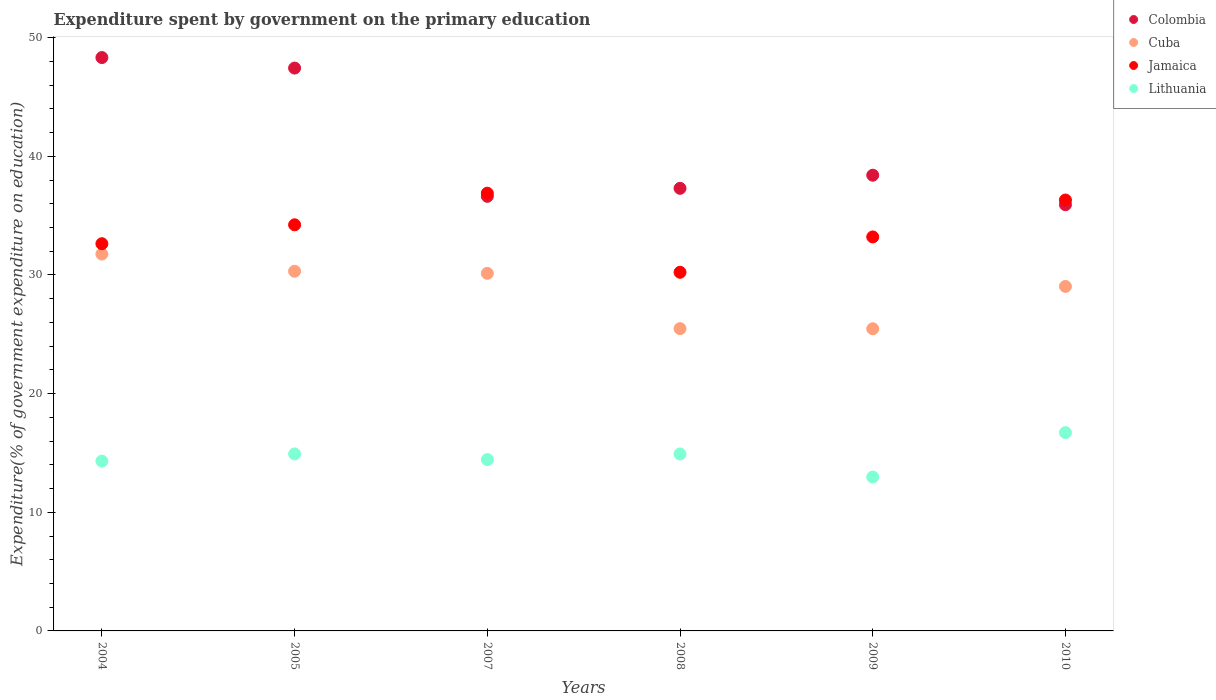What is the expenditure spent by government on the primary education in Cuba in 2004?
Offer a very short reply. 31.76. Across all years, what is the maximum expenditure spent by government on the primary education in Cuba?
Your response must be concise. 31.76. Across all years, what is the minimum expenditure spent by government on the primary education in Lithuania?
Keep it short and to the point. 12.97. In which year was the expenditure spent by government on the primary education in Colombia maximum?
Ensure brevity in your answer.  2004. What is the total expenditure spent by government on the primary education in Colombia in the graph?
Offer a very short reply. 244.02. What is the difference between the expenditure spent by government on the primary education in Colombia in 2007 and that in 2009?
Provide a short and direct response. -1.78. What is the difference between the expenditure spent by government on the primary education in Jamaica in 2004 and the expenditure spent by government on the primary education in Cuba in 2007?
Keep it short and to the point. 2.5. What is the average expenditure spent by government on the primary education in Jamaica per year?
Offer a very short reply. 33.92. In the year 2008, what is the difference between the expenditure spent by government on the primary education in Lithuania and expenditure spent by government on the primary education in Colombia?
Provide a short and direct response. -22.39. In how many years, is the expenditure spent by government on the primary education in Colombia greater than 42 %?
Your response must be concise. 2. What is the ratio of the expenditure spent by government on the primary education in Colombia in 2004 to that in 2010?
Offer a terse response. 1.35. Is the expenditure spent by government on the primary education in Lithuania in 2005 less than that in 2007?
Ensure brevity in your answer.  No. What is the difference between the highest and the second highest expenditure spent by government on the primary education in Jamaica?
Ensure brevity in your answer.  0.58. What is the difference between the highest and the lowest expenditure spent by government on the primary education in Colombia?
Give a very brief answer. 12.4. Is the sum of the expenditure spent by government on the primary education in Colombia in 2007 and 2009 greater than the maximum expenditure spent by government on the primary education in Lithuania across all years?
Provide a succinct answer. Yes. Is it the case that in every year, the sum of the expenditure spent by government on the primary education in Colombia and expenditure spent by government on the primary education in Lithuania  is greater than the expenditure spent by government on the primary education in Cuba?
Provide a short and direct response. Yes. Is the expenditure spent by government on the primary education in Lithuania strictly greater than the expenditure spent by government on the primary education in Cuba over the years?
Offer a terse response. No. Is the expenditure spent by government on the primary education in Cuba strictly less than the expenditure spent by government on the primary education in Jamaica over the years?
Offer a terse response. Yes. How many years are there in the graph?
Make the answer very short. 6. Are the values on the major ticks of Y-axis written in scientific E-notation?
Provide a succinct answer. No. Does the graph contain grids?
Provide a succinct answer. No. Where does the legend appear in the graph?
Give a very brief answer. Top right. How many legend labels are there?
Your answer should be compact. 4. What is the title of the graph?
Offer a very short reply. Expenditure spent by government on the primary education. What is the label or title of the Y-axis?
Your answer should be very brief. Expenditure(% of government expenditure on education). What is the Expenditure(% of government expenditure on education) of Colombia in 2004?
Offer a terse response. 48.32. What is the Expenditure(% of government expenditure on education) in Cuba in 2004?
Provide a short and direct response. 31.76. What is the Expenditure(% of government expenditure on education) in Jamaica in 2004?
Provide a short and direct response. 32.63. What is the Expenditure(% of government expenditure on education) of Lithuania in 2004?
Ensure brevity in your answer.  14.31. What is the Expenditure(% of government expenditure on education) of Colombia in 2005?
Offer a very short reply. 47.44. What is the Expenditure(% of government expenditure on education) of Cuba in 2005?
Give a very brief answer. 30.31. What is the Expenditure(% of government expenditure on education) in Jamaica in 2005?
Ensure brevity in your answer.  34.23. What is the Expenditure(% of government expenditure on education) in Lithuania in 2005?
Give a very brief answer. 14.92. What is the Expenditure(% of government expenditure on education) in Colombia in 2007?
Your answer should be very brief. 36.63. What is the Expenditure(% of government expenditure on education) in Cuba in 2007?
Your response must be concise. 30.14. What is the Expenditure(% of government expenditure on education) in Jamaica in 2007?
Make the answer very short. 36.89. What is the Expenditure(% of government expenditure on education) of Lithuania in 2007?
Give a very brief answer. 14.44. What is the Expenditure(% of government expenditure on education) of Colombia in 2008?
Make the answer very short. 37.3. What is the Expenditure(% of government expenditure on education) in Cuba in 2008?
Give a very brief answer. 25.48. What is the Expenditure(% of government expenditure on education) in Jamaica in 2008?
Your response must be concise. 30.23. What is the Expenditure(% of government expenditure on education) in Lithuania in 2008?
Your answer should be compact. 14.92. What is the Expenditure(% of government expenditure on education) of Colombia in 2009?
Give a very brief answer. 38.41. What is the Expenditure(% of government expenditure on education) in Cuba in 2009?
Offer a very short reply. 25.47. What is the Expenditure(% of government expenditure on education) of Jamaica in 2009?
Your answer should be very brief. 33.21. What is the Expenditure(% of government expenditure on education) of Lithuania in 2009?
Offer a terse response. 12.97. What is the Expenditure(% of government expenditure on education) in Colombia in 2010?
Keep it short and to the point. 35.92. What is the Expenditure(% of government expenditure on education) of Cuba in 2010?
Keep it short and to the point. 29.04. What is the Expenditure(% of government expenditure on education) of Jamaica in 2010?
Keep it short and to the point. 36.32. What is the Expenditure(% of government expenditure on education) in Lithuania in 2010?
Keep it short and to the point. 16.71. Across all years, what is the maximum Expenditure(% of government expenditure on education) in Colombia?
Your answer should be very brief. 48.32. Across all years, what is the maximum Expenditure(% of government expenditure on education) in Cuba?
Offer a very short reply. 31.76. Across all years, what is the maximum Expenditure(% of government expenditure on education) in Jamaica?
Your response must be concise. 36.89. Across all years, what is the maximum Expenditure(% of government expenditure on education) of Lithuania?
Ensure brevity in your answer.  16.71. Across all years, what is the minimum Expenditure(% of government expenditure on education) of Colombia?
Your response must be concise. 35.92. Across all years, what is the minimum Expenditure(% of government expenditure on education) of Cuba?
Provide a succinct answer. 25.47. Across all years, what is the minimum Expenditure(% of government expenditure on education) in Jamaica?
Provide a succinct answer. 30.23. Across all years, what is the minimum Expenditure(% of government expenditure on education) of Lithuania?
Give a very brief answer. 12.97. What is the total Expenditure(% of government expenditure on education) of Colombia in the graph?
Your response must be concise. 244.02. What is the total Expenditure(% of government expenditure on education) in Cuba in the graph?
Your answer should be very brief. 172.19. What is the total Expenditure(% of government expenditure on education) of Jamaica in the graph?
Provide a short and direct response. 203.5. What is the total Expenditure(% of government expenditure on education) in Lithuania in the graph?
Your answer should be compact. 88.27. What is the difference between the Expenditure(% of government expenditure on education) of Colombia in 2004 and that in 2005?
Your answer should be compact. 0.89. What is the difference between the Expenditure(% of government expenditure on education) of Cuba in 2004 and that in 2005?
Ensure brevity in your answer.  1.45. What is the difference between the Expenditure(% of government expenditure on education) in Jamaica in 2004 and that in 2005?
Your answer should be very brief. -1.59. What is the difference between the Expenditure(% of government expenditure on education) of Lithuania in 2004 and that in 2005?
Keep it short and to the point. -0.6. What is the difference between the Expenditure(% of government expenditure on education) in Colombia in 2004 and that in 2007?
Ensure brevity in your answer.  11.7. What is the difference between the Expenditure(% of government expenditure on education) in Cuba in 2004 and that in 2007?
Offer a very short reply. 1.62. What is the difference between the Expenditure(% of government expenditure on education) of Jamaica in 2004 and that in 2007?
Your answer should be very brief. -4.26. What is the difference between the Expenditure(% of government expenditure on education) in Lithuania in 2004 and that in 2007?
Your answer should be very brief. -0.13. What is the difference between the Expenditure(% of government expenditure on education) of Colombia in 2004 and that in 2008?
Make the answer very short. 11.02. What is the difference between the Expenditure(% of government expenditure on education) of Cuba in 2004 and that in 2008?
Provide a succinct answer. 6.28. What is the difference between the Expenditure(% of government expenditure on education) in Jamaica in 2004 and that in 2008?
Provide a succinct answer. 2.41. What is the difference between the Expenditure(% of government expenditure on education) in Lithuania in 2004 and that in 2008?
Your answer should be very brief. -0.6. What is the difference between the Expenditure(% of government expenditure on education) in Colombia in 2004 and that in 2009?
Offer a terse response. 9.92. What is the difference between the Expenditure(% of government expenditure on education) of Cuba in 2004 and that in 2009?
Your answer should be compact. 6.29. What is the difference between the Expenditure(% of government expenditure on education) in Jamaica in 2004 and that in 2009?
Your answer should be compact. -0.57. What is the difference between the Expenditure(% of government expenditure on education) of Lithuania in 2004 and that in 2009?
Keep it short and to the point. 1.34. What is the difference between the Expenditure(% of government expenditure on education) of Colombia in 2004 and that in 2010?
Provide a short and direct response. 12.4. What is the difference between the Expenditure(% of government expenditure on education) of Cuba in 2004 and that in 2010?
Offer a very short reply. 2.73. What is the difference between the Expenditure(% of government expenditure on education) of Jamaica in 2004 and that in 2010?
Offer a very short reply. -3.68. What is the difference between the Expenditure(% of government expenditure on education) in Lithuania in 2004 and that in 2010?
Give a very brief answer. -2.4. What is the difference between the Expenditure(% of government expenditure on education) of Colombia in 2005 and that in 2007?
Your answer should be compact. 10.81. What is the difference between the Expenditure(% of government expenditure on education) of Cuba in 2005 and that in 2007?
Your answer should be compact. 0.17. What is the difference between the Expenditure(% of government expenditure on education) of Jamaica in 2005 and that in 2007?
Provide a short and direct response. -2.66. What is the difference between the Expenditure(% of government expenditure on education) of Lithuania in 2005 and that in 2007?
Ensure brevity in your answer.  0.47. What is the difference between the Expenditure(% of government expenditure on education) in Colombia in 2005 and that in 2008?
Your answer should be compact. 10.13. What is the difference between the Expenditure(% of government expenditure on education) in Cuba in 2005 and that in 2008?
Your answer should be compact. 4.83. What is the difference between the Expenditure(% of government expenditure on education) in Jamaica in 2005 and that in 2008?
Make the answer very short. 4. What is the difference between the Expenditure(% of government expenditure on education) of Lithuania in 2005 and that in 2008?
Provide a succinct answer. 0. What is the difference between the Expenditure(% of government expenditure on education) in Colombia in 2005 and that in 2009?
Your response must be concise. 9.03. What is the difference between the Expenditure(% of government expenditure on education) of Cuba in 2005 and that in 2009?
Your answer should be very brief. 4.85. What is the difference between the Expenditure(% of government expenditure on education) in Jamaica in 2005 and that in 2009?
Ensure brevity in your answer.  1.02. What is the difference between the Expenditure(% of government expenditure on education) of Lithuania in 2005 and that in 2009?
Provide a short and direct response. 1.95. What is the difference between the Expenditure(% of government expenditure on education) of Colombia in 2005 and that in 2010?
Offer a very short reply. 11.52. What is the difference between the Expenditure(% of government expenditure on education) in Cuba in 2005 and that in 2010?
Provide a succinct answer. 1.28. What is the difference between the Expenditure(% of government expenditure on education) in Jamaica in 2005 and that in 2010?
Your response must be concise. -2.09. What is the difference between the Expenditure(% of government expenditure on education) of Lithuania in 2005 and that in 2010?
Offer a very short reply. -1.8. What is the difference between the Expenditure(% of government expenditure on education) in Colombia in 2007 and that in 2008?
Make the answer very short. -0.67. What is the difference between the Expenditure(% of government expenditure on education) in Cuba in 2007 and that in 2008?
Offer a terse response. 4.66. What is the difference between the Expenditure(% of government expenditure on education) of Jamaica in 2007 and that in 2008?
Ensure brevity in your answer.  6.67. What is the difference between the Expenditure(% of government expenditure on education) in Lithuania in 2007 and that in 2008?
Give a very brief answer. -0.47. What is the difference between the Expenditure(% of government expenditure on education) of Colombia in 2007 and that in 2009?
Offer a terse response. -1.78. What is the difference between the Expenditure(% of government expenditure on education) of Cuba in 2007 and that in 2009?
Offer a terse response. 4.67. What is the difference between the Expenditure(% of government expenditure on education) in Jamaica in 2007 and that in 2009?
Provide a succinct answer. 3.69. What is the difference between the Expenditure(% of government expenditure on education) of Lithuania in 2007 and that in 2009?
Your response must be concise. 1.47. What is the difference between the Expenditure(% of government expenditure on education) in Colombia in 2007 and that in 2010?
Give a very brief answer. 0.71. What is the difference between the Expenditure(% of government expenditure on education) in Cuba in 2007 and that in 2010?
Offer a very short reply. 1.1. What is the difference between the Expenditure(% of government expenditure on education) in Jamaica in 2007 and that in 2010?
Offer a very short reply. 0.58. What is the difference between the Expenditure(% of government expenditure on education) in Lithuania in 2007 and that in 2010?
Your answer should be compact. -2.27. What is the difference between the Expenditure(% of government expenditure on education) of Colombia in 2008 and that in 2009?
Ensure brevity in your answer.  -1.1. What is the difference between the Expenditure(% of government expenditure on education) in Cuba in 2008 and that in 2009?
Offer a terse response. 0.01. What is the difference between the Expenditure(% of government expenditure on education) of Jamaica in 2008 and that in 2009?
Your response must be concise. -2.98. What is the difference between the Expenditure(% of government expenditure on education) in Lithuania in 2008 and that in 2009?
Make the answer very short. 1.95. What is the difference between the Expenditure(% of government expenditure on education) in Colombia in 2008 and that in 2010?
Make the answer very short. 1.38. What is the difference between the Expenditure(% of government expenditure on education) of Cuba in 2008 and that in 2010?
Provide a short and direct response. -3.56. What is the difference between the Expenditure(% of government expenditure on education) of Jamaica in 2008 and that in 2010?
Your answer should be very brief. -6.09. What is the difference between the Expenditure(% of government expenditure on education) of Lithuania in 2008 and that in 2010?
Your answer should be very brief. -1.8. What is the difference between the Expenditure(% of government expenditure on education) in Colombia in 2009 and that in 2010?
Provide a succinct answer. 2.49. What is the difference between the Expenditure(% of government expenditure on education) of Cuba in 2009 and that in 2010?
Your answer should be compact. -3.57. What is the difference between the Expenditure(% of government expenditure on education) of Jamaica in 2009 and that in 2010?
Your response must be concise. -3.11. What is the difference between the Expenditure(% of government expenditure on education) of Lithuania in 2009 and that in 2010?
Offer a very short reply. -3.74. What is the difference between the Expenditure(% of government expenditure on education) of Colombia in 2004 and the Expenditure(% of government expenditure on education) of Cuba in 2005?
Your response must be concise. 18.01. What is the difference between the Expenditure(% of government expenditure on education) of Colombia in 2004 and the Expenditure(% of government expenditure on education) of Jamaica in 2005?
Your response must be concise. 14.1. What is the difference between the Expenditure(% of government expenditure on education) of Colombia in 2004 and the Expenditure(% of government expenditure on education) of Lithuania in 2005?
Your answer should be very brief. 33.41. What is the difference between the Expenditure(% of government expenditure on education) in Cuba in 2004 and the Expenditure(% of government expenditure on education) in Jamaica in 2005?
Keep it short and to the point. -2.47. What is the difference between the Expenditure(% of government expenditure on education) of Cuba in 2004 and the Expenditure(% of government expenditure on education) of Lithuania in 2005?
Your response must be concise. 16.84. What is the difference between the Expenditure(% of government expenditure on education) in Jamaica in 2004 and the Expenditure(% of government expenditure on education) in Lithuania in 2005?
Your response must be concise. 17.72. What is the difference between the Expenditure(% of government expenditure on education) in Colombia in 2004 and the Expenditure(% of government expenditure on education) in Cuba in 2007?
Provide a short and direct response. 18.19. What is the difference between the Expenditure(% of government expenditure on education) of Colombia in 2004 and the Expenditure(% of government expenditure on education) of Jamaica in 2007?
Provide a short and direct response. 11.43. What is the difference between the Expenditure(% of government expenditure on education) in Colombia in 2004 and the Expenditure(% of government expenditure on education) in Lithuania in 2007?
Offer a terse response. 33.88. What is the difference between the Expenditure(% of government expenditure on education) of Cuba in 2004 and the Expenditure(% of government expenditure on education) of Jamaica in 2007?
Provide a short and direct response. -5.13. What is the difference between the Expenditure(% of government expenditure on education) in Cuba in 2004 and the Expenditure(% of government expenditure on education) in Lithuania in 2007?
Offer a terse response. 17.32. What is the difference between the Expenditure(% of government expenditure on education) of Jamaica in 2004 and the Expenditure(% of government expenditure on education) of Lithuania in 2007?
Keep it short and to the point. 18.19. What is the difference between the Expenditure(% of government expenditure on education) in Colombia in 2004 and the Expenditure(% of government expenditure on education) in Cuba in 2008?
Provide a short and direct response. 22.85. What is the difference between the Expenditure(% of government expenditure on education) in Colombia in 2004 and the Expenditure(% of government expenditure on education) in Jamaica in 2008?
Your answer should be very brief. 18.1. What is the difference between the Expenditure(% of government expenditure on education) of Colombia in 2004 and the Expenditure(% of government expenditure on education) of Lithuania in 2008?
Your answer should be very brief. 33.41. What is the difference between the Expenditure(% of government expenditure on education) in Cuba in 2004 and the Expenditure(% of government expenditure on education) in Jamaica in 2008?
Your answer should be very brief. 1.53. What is the difference between the Expenditure(% of government expenditure on education) of Cuba in 2004 and the Expenditure(% of government expenditure on education) of Lithuania in 2008?
Your answer should be compact. 16.85. What is the difference between the Expenditure(% of government expenditure on education) in Jamaica in 2004 and the Expenditure(% of government expenditure on education) in Lithuania in 2008?
Provide a succinct answer. 17.72. What is the difference between the Expenditure(% of government expenditure on education) in Colombia in 2004 and the Expenditure(% of government expenditure on education) in Cuba in 2009?
Ensure brevity in your answer.  22.86. What is the difference between the Expenditure(% of government expenditure on education) of Colombia in 2004 and the Expenditure(% of government expenditure on education) of Jamaica in 2009?
Ensure brevity in your answer.  15.12. What is the difference between the Expenditure(% of government expenditure on education) in Colombia in 2004 and the Expenditure(% of government expenditure on education) in Lithuania in 2009?
Your response must be concise. 35.35. What is the difference between the Expenditure(% of government expenditure on education) of Cuba in 2004 and the Expenditure(% of government expenditure on education) of Jamaica in 2009?
Ensure brevity in your answer.  -1.45. What is the difference between the Expenditure(% of government expenditure on education) in Cuba in 2004 and the Expenditure(% of government expenditure on education) in Lithuania in 2009?
Offer a very short reply. 18.79. What is the difference between the Expenditure(% of government expenditure on education) of Jamaica in 2004 and the Expenditure(% of government expenditure on education) of Lithuania in 2009?
Your answer should be compact. 19.66. What is the difference between the Expenditure(% of government expenditure on education) of Colombia in 2004 and the Expenditure(% of government expenditure on education) of Cuba in 2010?
Give a very brief answer. 19.29. What is the difference between the Expenditure(% of government expenditure on education) of Colombia in 2004 and the Expenditure(% of government expenditure on education) of Jamaica in 2010?
Offer a terse response. 12.01. What is the difference between the Expenditure(% of government expenditure on education) in Colombia in 2004 and the Expenditure(% of government expenditure on education) in Lithuania in 2010?
Your answer should be very brief. 31.61. What is the difference between the Expenditure(% of government expenditure on education) of Cuba in 2004 and the Expenditure(% of government expenditure on education) of Jamaica in 2010?
Give a very brief answer. -4.56. What is the difference between the Expenditure(% of government expenditure on education) in Cuba in 2004 and the Expenditure(% of government expenditure on education) in Lithuania in 2010?
Ensure brevity in your answer.  15.05. What is the difference between the Expenditure(% of government expenditure on education) in Jamaica in 2004 and the Expenditure(% of government expenditure on education) in Lithuania in 2010?
Give a very brief answer. 15.92. What is the difference between the Expenditure(% of government expenditure on education) of Colombia in 2005 and the Expenditure(% of government expenditure on education) of Cuba in 2007?
Offer a terse response. 17.3. What is the difference between the Expenditure(% of government expenditure on education) of Colombia in 2005 and the Expenditure(% of government expenditure on education) of Jamaica in 2007?
Offer a terse response. 10.55. What is the difference between the Expenditure(% of government expenditure on education) in Colombia in 2005 and the Expenditure(% of government expenditure on education) in Lithuania in 2007?
Your answer should be very brief. 32.99. What is the difference between the Expenditure(% of government expenditure on education) in Cuba in 2005 and the Expenditure(% of government expenditure on education) in Jamaica in 2007?
Offer a very short reply. -6.58. What is the difference between the Expenditure(% of government expenditure on education) in Cuba in 2005 and the Expenditure(% of government expenditure on education) in Lithuania in 2007?
Your answer should be compact. 15.87. What is the difference between the Expenditure(% of government expenditure on education) of Jamaica in 2005 and the Expenditure(% of government expenditure on education) of Lithuania in 2007?
Provide a short and direct response. 19.78. What is the difference between the Expenditure(% of government expenditure on education) in Colombia in 2005 and the Expenditure(% of government expenditure on education) in Cuba in 2008?
Offer a terse response. 21.96. What is the difference between the Expenditure(% of government expenditure on education) of Colombia in 2005 and the Expenditure(% of government expenditure on education) of Jamaica in 2008?
Make the answer very short. 17.21. What is the difference between the Expenditure(% of government expenditure on education) of Colombia in 2005 and the Expenditure(% of government expenditure on education) of Lithuania in 2008?
Offer a very short reply. 32.52. What is the difference between the Expenditure(% of government expenditure on education) of Cuba in 2005 and the Expenditure(% of government expenditure on education) of Jamaica in 2008?
Ensure brevity in your answer.  0.09. What is the difference between the Expenditure(% of government expenditure on education) of Cuba in 2005 and the Expenditure(% of government expenditure on education) of Lithuania in 2008?
Keep it short and to the point. 15.4. What is the difference between the Expenditure(% of government expenditure on education) of Jamaica in 2005 and the Expenditure(% of government expenditure on education) of Lithuania in 2008?
Give a very brief answer. 19.31. What is the difference between the Expenditure(% of government expenditure on education) of Colombia in 2005 and the Expenditure(% of government expenditure on education) of Cuba in 2009?
Keep it short and to the point. 21.97. What is the difference between the Expenditure(% of government expenditure on education) in Colombia in 2005 and the Expenditure(% of government expenditure on education) in Jamaica in 2009?
Your answer should be very brief. 14.23. What is the difference between the Expenditure(% of government expenditure on education) in Colombia in 2005 and the Expenditure(% of government expenditure on education) in Lithuania in 2009?
Provide a succinct answer. 34.47. What is the difference between the Expenditure(% of government expenditure on education) of Cuba in 2005 and the Expenditure(% of government expenditure on education) of Jamaica in 2009?
Provide a short and direct response. -2.89. What is the difference between the Expenditure(% of government expenditure on education) of Cuba in 2005 and the Expenditure(% of government expenditure on education) of Lithuania in 2009?
Give a very brief answer. 17.34. What is the difference between the Expenditure(% of government expenditure on education) in Jamaica in 2005 and the Expenditure(% of government expenditure on education) in Lithuania in 2009?
Give a very brief answer. 21.26. What is the difference between the Expenditure(% of government expenditure on education) in Colombia in 2005 and the Expenditure(% of government expenditure on education) in Cuba in 2010?
Offer a very short reply. 18.4. What is the difference between the Expenditure(% of government expenditure on education) of Colombia in 2005 and the Expenditure(% of government expenditure on education) of Jamaica in 2010?
Provide a short and direct response. 11.12. What is the difference between the Expenditure(% of government expenditure on education) of Colombia in 2005 and the Expenditure(% of government expenditure on education) of Lithuania in 2010?
Make the answer very short. 30.72. What is the difference between the Expenditure(% of government expenditure on education) in Cuba in 2005 and the Expenditure(% of government expenditure on education) in Jamaica in 2010?
Offer a terse response. -6. What is the difference between the Expenditure(% of government expenditure on education) in Cuba in 2005 and the Expenditure(% of government expenditure on education) in Lithuania in 2010?
Keep it short and to the point. 13.6. What is the difference between the Expenditure(% of government expenditure on education) of Jamaica in 2005 and the Expenditure(% of government expenditure on education) of Lithuania in 2010?
Make the answer very short. 17.51. What is the difference between the Expenditure(% of government expenditure on education) in Colombia in 2007 and the Expenditure(% of government expenditure on education) in Cuba in 2008?
Give a very brief answer. 11.15. What is the difference between the Expenditure(% of government expenditure on education) of Colombia in 2007 and the Expenditure(% of government expenditure on education) of Jamaica in 2008?
Your answer should be very brief. 6.4. What is the difference between the Expenditure(% of government expenditure on education) of Colombia in 2007 and the Expenditure(% of government expenditure on education) of Lithuania in 2008?
Provide a succinct answer. 21.71. What is the difference between the Expenditure(% of government expenditure on education) of Cuba in 2007 and the Expenditure(% of government expenditure on education) of Jamaica in 2008?
Give a very brief answer. -0.09. What is the difference between the Expenditure(% of government expenditure on education) of Cuba in 2007 and the Expenditure(% of government expenditure on education) of Lithuania in 2008?
Your answer should be compact. 15.22. What is the difference between the Expenditure(% of government expenditure on education) in Jamaica in 2007 and the Expenditure(% of government expenditure on education) in Lithuania in 2008?
Your response must be concise. 21.98. What is the difference between the Expenditure(% of government expenditure on education) in Colombia in 2007 and the Expenditure(% of government expenditure on education) in Cuba in 2009?
Ensure brevity in your answer.  11.16. What is the difference between the Expenditure(% of government expenditure on education) in Colombia in 2007 and the Expenditure(% of government expenditure on education) in Jamaica in 2009?
Keep it short and to the point. 3.42. What is the difference between the Expenditure(% of government expenditure on education) of Colombia in 2007 and the Expenditure(% of government expenditure on education) of Lithuania in 2009?
Offer a very short reply. 23.66. What is the difference between the Expenditure(% of government expenditure on education) of Cuba in 2007 and the Expenditure(% of government expenditure on education) of Jamaica in 2009?
Your answer should be compact. -3.07. What is the difference between the Expenditure(% of government expenditure on education) of Cuba in 2007 and the Expenditure(% of government expenditure on education) of Lithuania in 2009?
Your response must be concise. 17.17. What is the difference between the Expenditure(% of government expenditure on education) in Jamaica in 2007 and the Expenditure(% of government expenditure on education) in Lithuania in 2009?
Offer a terse response. 23.92. What is the difference between the Expenditure(% of government expenditure on education) of Colombia in 2007 and the Expenditure(% of government expenditure on education) of Cuba in 2010?
Give a very brief answer. 7.59. What is the difference between the Expenditure(% of government expenditure on education) of Colombia in 2007 and the Expenditure(% of government expenditure on education) of Jamaica in 2010?
Keep it short and to the point. 0.31. What is the difference between the Expenditure(% of government expenditure on education) in Colombia in 2007 and the Expenditure(% of government expenditure on education) in Lithuania in 2010?
Ensure brevity in your answer.  19.91. What is the difference between the Expenditure(% of government expenditure on education) in Cuba in 2007 and the Expenditure(% of government expenditure on education) in Jamaica in 2010?
Keep it short and to the point. -6.18. What is the difference between the Expenditure(% of government expenditure on education) of Cuba in 2007 and the Expenditure(% of government expenditure on education) of Lithuania in 2010?
Offer a very short reply. 13.42. What is the difference between the Expenditure(% of government expenditure on education) in Jamaica in 2007 and the Expenditure(% of government expenditure on education) in Lithuania in 2010?
Keep it short and to the point. 20.18. What is the difference between the Expenditure(% of government expenditure on education) of Colombia in 2008 and the Expenditure(% of government expenditure on education) of Cuba in 2009?
Offer a very short reply. 11.84. What is the difference between the Expenditure(% of government expenditure on education) of Colombia in 2008 and the Expenditure(% of government expenditure on education) of Jamaica in 2009?
Offer a terse response. 4.1. What is the difference between the Expenditure(% of government expenditure on education) of Colombia in 2008 and the Expenditure(% of government expenditure on education) of Lithuania in 2009?
Offer a terse response. 24.33. What is the difference between the Expenditure(% of government expenditure on education) of Cuba in 2008 and the Expenditure(% of government expenditure on education) of Jamaica in 2009?
Your response must be concise. -7.73. What is the difference between the Expenditure(% of government expenditure on education) of Cuba in 2008 and the Expenditure(% of government expenditure on education) of Lithuania in 2009?
Offer a terse response. 12.51. What is the difference between the Expenditure(% of government expenditure on education) in Jamaica in 2008 and the Expenditure(% of government expenditure on education) in Lithuania in 2009?
Provide a succinct answer. 17.26. What is the difference between the Expenditure(% of government expenditure on education) of Colombia in 2008 and the Expenditure(% of government expenditure on education) of Cuba in 2010?
Make the answer very short. 8.27. What is the difference between the Expenditure(% of government expenditure on education) of Colombia in 2008 and the Expenditure(% of government expenditure on education) of Jamaica in 2010?
Your answer should be compact. 0.99. What is the difference between the Expenditure(% of government expenditure on education) of Colombia in 2008 and the Expenditure(% of government expenditure on education) of Lithuania in 2010?
Your answer should be compact. 20.59. What is the difference between the Expenditure(% of government expenditure on education) of Cuba in 2008 and the Expenditure(% of government expenditure on education) of Jamaica in 2010?
Make the answer very short. -10.84. What is the difference between the Expenditure(% of government expenditure on education) of Cuba in 2008 and the Expenditure(% of government expenditure on education) of Lithuania in 2010?
Offer a very short reply. 8.76. What is the difference between the Expenditure(% of government expenditure on education) of Jamaica in 2008 and the Expenditure(% of government expenditure on education) of Lithuania in 2010?
Ensure brevity in your answer.  13.51. What is the difference between the Expenditure(% of government expenditure on education) in Colombia in 2009 and the Expenditure(% of government expenditure on education) in Cuba in 2010?
Offer a very short reply. 9.37. What is the difference between the Expenditure(% of government expenditure on education) in Colombia in 2009 and the Expenditure(% of government expenditure on education) in Jamaica in 2010?
Keep it short and to the point. 2.09. What is the difference between the Expenditure(% of government expenditure on education) in Colombia in 2009 and the Expenditure(% of government expenditure on education) in Lithuania in 2010?
Your answer should be compact. 21.69. What is the difference between the Expenditure(% of government expenditure on education) of Cuba in 2009 and the Expenditure(% of government expenditure on education) of Jamaica in 2010?
Provide a succinct answer. -10.85. What is the difference between the Expenditure(% of government expenditure on education) of Cuba in 2009 and the Expenditure(% of government expenditure on education) of Lithuania in 2010?
Keep it short and to the point. 8.75. What is the difference between the Expenditure(% of government expenditure on education) of Jamaica in 2009 and the Expenditure(% of government expenditure on education) of Lithuania in 2010?
Make the answer very short. 16.49. What is the average Expenditure(% of government expenditure on education) in Colombia per year?
Your answer should be very brief. 40.67. What is the average Expenditure(% of government expenditure on education) of Cuba per year?
Give a very brief answer. 28.7. What is the average Expenditure(% of government expenditure on education) of Jamaica per year?
Offer a very short reply. 33.92. What is the average Expenditure(% of government expenditure on education) in Lithuania per year?
Make the answer very short. 14.71. In the year 2004, what is the difference between the Expenditure(% of government expenditure on education) of Colombia and Expenditure(% of government expenditure on education) of Cuba?
Make the answer very short. 16.56. In the year 2004, what is the difference between the Expenditure(% of government expenditure on education) of Colombia and Expenditure(% of government expenditure on education) of Jamaica?
Keep it short and to the point. 15.69. In the year 2004, what is the difference between the Expenditure(% of government expenditure on education) in Colombia and Expenditure(% of government expenditure on education) in Lithuania?
Keep it short and to the point. 34.01. In the year 2004, what is the difference between the Expenditure(% of government expenditure on education) of Cuba and Expenditure(% of government expenditure on education) of Jamaica?
Provide a short and direct response. -0.87. In the year 2004, what is the difference between the Expenditure(% of government expenditure on education) in Cuba and Expenditure(% of government expenditure on education) in Lithuania?
Your response must be concise. 17.45. In the year 2004, what is the difference between the Expenditure(% of government expenditure on education) in Jamaica and Expenditure(% of government expenditure on education) in Lithuania?
Offer a very short reply. 18.32. In the year 2005, what is the difference between the Expenditure(% of government expenditure on education) in Colombia and Expenditure(% of government expenditure on education) in Cuba?
Offer a terse response. 17.12. In the year 2005, what is the difference between the Expenditure(% of government expenditure on education) in Colombia and Expenditure(% of government expenditure on education) in Jamaica?
Your answer should be very brief. 13.21. In the year 2005, what is the difference between the Expenditure(% of government expenditure on education) in Colombia and Expenditure(% of government expenditure on education) in Lithuania?
Give a very brief answer. 32.52. In the year 2005, what is the difference between the Expenditure(% of government expenditure on education) of Cuba and Expenditure(% of government expenditure on education) of Jamaica?
Provide a short and direct response. -3.91. In the year 2005, what is the difference between the Expenditure(% of government expenditure on education) of Cuba and Expenditure(% of government expenditure on education) of Lithuania?
Your response must be concise. 15.4. In the year 2005, what is the difference between the Expenditure(% of government expenditure on education) of Jamaica and Expenditure(% of government expenditure on education) of Lithuania?
Ensure brevity in your answer.  19.31. In the year 2007, what is the difference between the Expenditure(% of government expenditure on education) in Colombia and Expenditure(% of government expenditure on education) in Cuba?
Your response must be concise. 6.49. In the year 2007, what is the difference between the Expenditure(% of government expenditure on education) of Colombia and Expenditure(% of government expenditure on education) of Jamaica?
Ensure brevity in your answer.  -0.26. In the year 2007, what is the difference between the Expenditure(% of government expenditure on education) of Colombia and Expenditure(% of government expenditure on education) of Lithuania?
Offer a terse response. 22.18. In the year 2007, what is the difference between the Expenditure(% of government expenditure on education) of Cuba and Expenditure(% of government expenditure on education) of Jamaica?
Keep it short and to the point. -6.75. In the year 2007, what is the difference between the Expenditure(% of government expenditure on education) in Cuba and Expenditure(% of government expenditure on education) in Lithuania?
Make the answer very short. 15.7. In the year 2007, what is the difference between the Expenditure(% of government expenditure on education) of Jamaica and Expenditure(% of government expenditure on education) of Lithuania?
Your response must be concise. 22.45. In the year 2008, what is the difference between the Expenditure(% of government expenditure on education) in Colombia and Expenditure(% of government expenditure on education) in Cuba?
Offer a very short reply. 11.82. In the year 2008, what is the difference between the Expenditure(% of government expenditure on education) of Colombia and Expenditure(% of government expenditure on education) of Jamaica?
Give a very brief answer. 7.08. In the year 2008, what is the difference between the Expenditure(% of government expenditure on education) in Colombia and Expenditure(% of government expenditure on education) in Lithuania?
Your response must be concise. 22.39. In the year 2008, what is the difference between the Expenditure(% of government expenditure on education) of Cuba and Expenditure(% of government expenditure on education) of Jamaica?
Make the answer very short. -4.75. In the year 2008, what is the difference between the Expenditure(% of government expenditure on education) of Cuba and Expenditure(% of government expenditure on education) of Lithuania?
Provide a short and direct response. 10.56. In the year 2008, what is the difference between the Expenditure(% of government expenditure on education) in Jamaica and Expenditure(% of government expenditure on education) in Lithuania?
Your answer should be compact. 15.31. In the year 2009, what is the difference between the Expenditure(% of government expenditure on education) of Colombia and Expenditure(% of government expenditure on education) of Cuba?
Your response must be concise. 12.94. In the year 2009, what is the difference between the Expenditure(% of government expenditure on education) of Colombia and Expenditure(% of government expenditure on education) of Jamaica?
Provide a succinct answer. 5.2. In the year 2009, what is the difference between the Expenditure(% of government expenditure on education) of Colombia and Expenditure(% of government expenditure on education) of Lithuania?
Provide a succinct answer. 25.44. In the year 2009, what is the difference between the Expenditure(% of government expenditure on education) in Cuba and Expenditure(% of government expenditure on education) in Jamaica?
Your answer should be very brief. -7.74. In the year 2009, what is the difference between the Expenditure(% of government expenditure on education) of Cuba and Expenditure(% of government expenditure on education) of Lithuania?
Your response must be concise. 12.5. In the year 2009, what is the difference between the Expenditure(% of government expenditure on education) of Jamaica and Expenditure(% of government expenditure on education) of Lithuania?
Give a very brief answer. 20.24. In the year 2010, what is the difference between the Expenditure(% of government expenditure on education) in Colombia and Expenditure(% of government expenditure on education) in Cuba?
Your answer should be very brief. 6.89. In the year 2010, what is the difference between the Expenditure(% of government expenditure on education) in Colombia and Expenditure(% of government expenditure on education) in Jamaica?
Ensure brevity in your answer.  -0.4. In the year 2010, what is the difference between the Expenditure(% of government expenditure on education) of Colombia and Expenditure(% of government expenditure on education) of Lithuania?
Make the answer very short. 19.21. In the year 2010, what is the difference between the Expenditure(% of government expenditure on education) of Cuba and Expenditure(% of government expenditure on education) of Jamaica?
Ensure brevity in your answer.  -7.28. In the year 2010, what is the difference between the Expenditure(% of government expenditure on education) in Cuba and Expenditure(% of government expenditure on education) in Lithuania?
Provide a short and direct response. 12.32. In the year 2010, what is the difference between the Expenditure(% of government expenditure on education) in Jamaica and Expenditure(% of government expenditure on education) in Lithuania?
Your response must be concise. 19.6. What is the ratio of the Expenditure(% of government expenditure on education) in Colombia in 2004 to that in 2005?
Your response must be concise. 1.02. What is the ratio of the Expenditure(% of government expenditure on education) of Cuba in 2004 to that in 2005?
Your response must be concise. 1.05. What is the ratio of the Expenditure(% of government expenditure on education) in Jamaica in 2004 to that in 2005?
Your answer should be compact. 0.95. What is the ratio of the Expenditure(% of government expenditure on education) in Lithuania in 2004 to that in 2005?
Offer a terse response. 0.96. What is the ratio of the Expenditure(% of government expenditure on education) in Colombia in 2004 to that in 2007?
Offer a very short reply. 1.32. What is the ratio of the Expenditure(% of government expenditure on education) of Cuba in 2004 to that in 2007?
Provide a short and direct response. 1.05. What is the ratio of the Expenditure(% of government expenditure on education) in Jamaica in 2004 to that in 2007?
Ensure brevity in your answer.  0.88. What is the ratio of the Expenditure(% of government expenditure on education) in Colombia in 2004 to that in 2008?
Offer a terse response. 1.3. What is the ratio of the Expenditure(% of government expenditure on education) of Cuba in 2004 to that in 2008?
Your answer should be very brief. 1.25. What is the ratio of the Expenditure(% of government expenditure on education) of Jamaica in 2004 to that in 2008?
Offer a terse response. 1.08. What is the ratio of the Expenditure(% of government expenditure on education) in Lithuania in 2004 to that in 2008?
Give a very brief answer. 0.96. What is the ratio of the Expenditure(% of government expenditure on education) of Colombia in 2004 to that in 2009?
Your answer should be very brief. 1.26. What is the ratio of the Expenditure(% of government expenditure on education) in Cuba in 2004 to that in 2009?
Give a very brief answer. 1.25. What is the ratio of the Expenditure(% of government expenditure on education) in Jamaica in 2004 to that in 2009?
Provide a short and direct response. 0.98. What is the ratio of the Expenditure(% of government expenditure on education) of Lithuania in 2004 to that in 2009?
Provide a succinct answer. 1.1. What is the ratio of the Expenditure(% of government expenditure on education) in Colombia in 2004 to that in 2010?
Provide a short and direct response. 1.35. What is the ratio of the Expenditure(% of government expenditure on education) of Cuba in 2004 to that in 2010?
Make the answer very short. 1.09. What is the ratio of the Expenditure(% of government expenditure on education) of Jamaica in 2004 to that in 2010?
Your answer should be compact. 0.9. What is the ratio of the Expenditure(% of government expenditure on education) of Lithuania in 2004 to that in 2010?
Your response must be concise. 0.86. What is the ratio of the Expenditure(% of government expenditure on education) of Colombia in 2005 to that in 2007?
Your answer should be very brief. 1.3. What is the ratio of the Expenditure(% of government expenditure on education) of Jamaica in 2005 to that in 2007?
Offer a very short reply. 0.93. What is the ratio of the Expenditure(% of government expenditure on education) of Lithuania in 2005 to that in 2007?
Provide a succinct answer. 1.03. What is the ratio of the Expenditure(% of government expenditure on education) of Colombia in 2005 to that in 2008?
Your answer should be very brief. 1.27. What is the ratio of the Expenditure(% of government expenditure on education) in Cuba in 2005 to that in 2008?
Offer a terse response. 1.19. What is the ratio of the Expenditure(% of government expenditure on education) of Jamaica in 2005 to that in 2008?
Keep it short and to the point. 1.13. What is the ratio of the Expenditure(% of government expenditure on education) of Lithuania in 2005 to that in 2008?
Provide a succinct answer. 1. What is the ratio of the Expenditure(% of government expenditure on education) in Colombia in 2005 to that in 2009?
Keep it short and to the point. 1.24. What is the ratio of the Expenditure(% of government expenditure on education) in Cuba in 2005 to that in 2009?
Provide a short and direct response. 1.19. What is the ratio of the Expenditure(% of government expenditure on education) in Jamaica in 2005 to that in 2009?
Keep it short and to the point. 1.03. What is the ratio of the Expenditure(% of government expenditure on education) of Lithuania in 2005 to that in 2009?
Offer a very short reply. 1.15. What is the ratio of the Expenditure(% of government expenditure on education) in Colombia in 2005 to that in 2010?
Your response must be concise. 1.32. What is the ratio of the Expenditure(% of government expenditure on education) of Cuba in 2005 to that in 2010?
Your response must be concise. 1.04. What is the ratio of the Expenditure(% of government expenditure on education) of Jamaica in 2005 to that in 2010?
Your answer should be compact. 0.94. What is the ratio of the Expenditure(% of government expenditure on education) of Lithuania in 2005 to that in 2010?
Your response must be concise. 0.89. What is the ratio of the Expenditure(% of government expenditure on education) of Colombia in 2007 to that in 2008?
Give a very brief answer. 0.98. What is the ratio of the Expenditure(% of government expenditure on education) of Cuba in 2007 to that in 2008?
Provide a short and direct response. 1.18. What is the ratio of the Expenditure(% of government expenditure on education) of Jamaica in 2007 to that in 2008?
Keep it short and to the point. 1.22. What is the ratio of the Expenditure(% of government expenditure on education) in Lithuania in 2007 to that in 2008?
Your answer should be compact. 0.97. What is the ratio of the Expenditure(% of government expenditure on education) of Colombia in 2007 to that in 2009?
Give a very brief answer. 0.95. What is the ratio of the Expenditure(% of government expenditure on education) in Cuba in 2007 to that in 2009?
Ensure brevity in your answer.  1.18. What is the ratio of the Expenditure(% of government expenditure on education) of Jamaica in 2007 to that in 2009?
Your answer should be compact. 1.11. What is the ratio of the Expenditure(% of government expenditure on education) in Lithuania in 2007 to that in 2009?
Provide a succinct answer. 1.11. What is the ratio of the Expenditure(% of government expenditure on education) of Colombia in 2007 to that in 2010?
Offer a very short reply. 1.02. What is the ratio of the Expenditure(% of government expenditure on education) in Cuba in 2007 to that in 2010?
Keep it short and to the point. 1.04. What is the ratio of the Expenditure(% of government expenditure on education) of Jamaica in 2007 to that in 2010?
Make the answer very short. 1.02. What is the ratio of the Expenditure(% of government expenditure on education) in Lithuania in 2007 to that in 2010?
Provide a succinct answer. 0.86. What is the ratio of the Expenditure(% of government expenditure on education) in Colombia in 2008 to that in 2009?
Provide a succinct answer. 0.97. What is the ratio of the Expenditure(% of government expenditure on education) in Cuba in 2008 to that in 2009?
Your answer should be compact. 1. What is the ratio of the Expenditure(% of government expenditure on education) of Jamaica in 2008 to that in 2009?
Your response must be concise. 0.91. What is the ratio of the Expenditure(% of government expenditure on education) of Lithuania in 2008 to that in 2009?
Ensure brevity in your answer.  1.15. What is the ratio of the Expenditure(% of government expenditure on education) of Colombia in 2008 to that in 2010?
Make the answer very short. 1.04. What is the ratio of the Expenditure(% of government expenditure on education) of Cuba in 2008 to that in 2010?
Your response must be concise. 0.88. What is the ratio of the Expenditure(% of government expenditure on education) of Jamaica in 2008 to that in 2010?
Offer a terse response. 0.83. What is the ratio of the Expenditure(% of government expenditure on education) of Lithuania in 2008 to that in 2010?
Your answer should be very brief. 0.89. What is the ratio of the Expenditure(% of government expenditure on education) in Colombia in 2009 to that in 2010?
Offer a very short reply. 1.07. What is the ratio of the Expenditure(% of government expenditure on education) in Cuba in 2009 to that in 2010?
Offer a terse response. 0.88. What is the ratio of the Expenditure(% of government expenditure on education) of Jamaica in 2009 to that in 2010?
Offer a terse response. 0.91. What is the ratio of the Expenditure(% of government expenditure on education) in Lithuania in 2009 to that in 2010?
Make the answer very short. 0.78. What is the difference between the highest and the second highest Expenditure(% of government expenditure on education) in Colombia?
Ensure brevity in your answer.  0.89. What is the difference between the highest and the second highest Expenditure(% of government expenditure on education) of Cuba?
Your answer should be compact. 1.45. What is the difference between the highest and the second highest Expenditure(% of government expenditure on education) of Jamaica?
Provide a short and direct response. 0.58. What is the difference between the highest and the second highest Expenditure(% of government expenditure on education) in Lithuania?
Your answer should be very brief. 1.8. What is the difference between the highest and the lowest Expenditure(% of government expenditure on education) in Colombia?
Your answer should be compact. 12.4. What is the difference between the highest and the lowest Expenditure(% of government expenditure on education) in Cuba?
Offer a very short reply. 6.29. What is the difference between the highest and the lowest Expenditure(% of government expenditure on education) of Jamaica?
Offer a very short reply. 6.67. What is the difference between the highest and the lowest Expenditure(% of government expenditure on education) of Lithuania?
Provide a succinct answer. 3.74. 